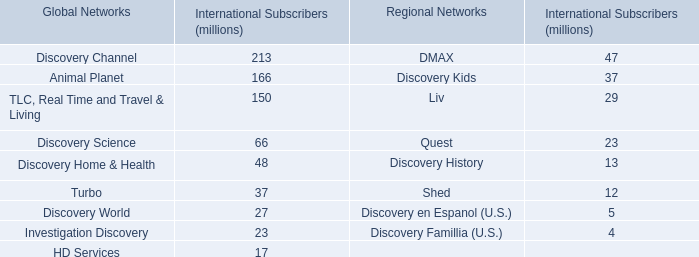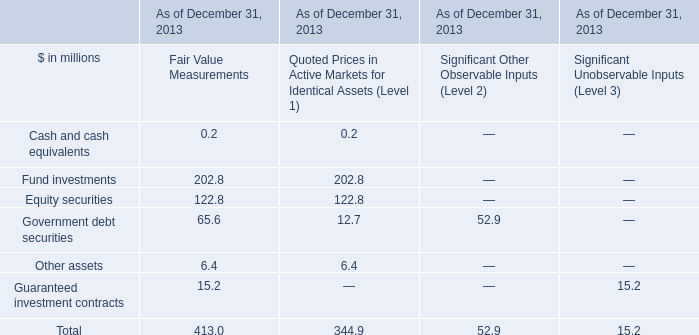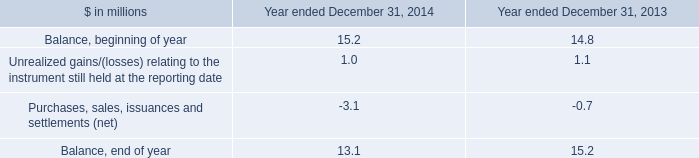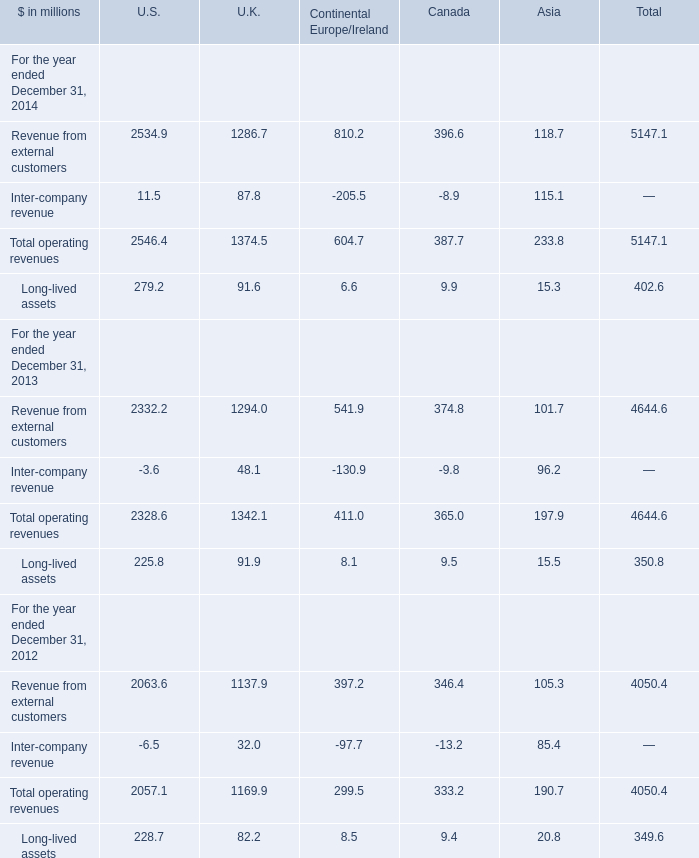What was the total operating revenues of U.S. in 2014 ? (in million) 
Computations: (2534.9 + 11.5)
Answer: 2546.4. 